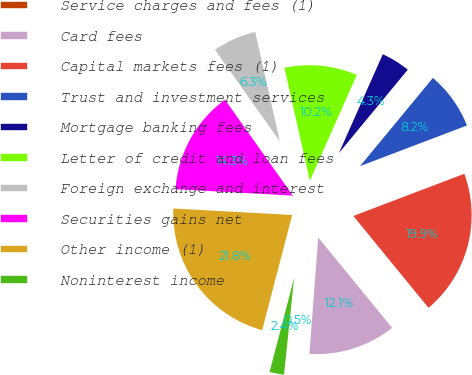Convert chart to OTSL. <chart><loc_0><loc_0><loc_500><loc_500><pie_chart><fcel>Service charges and fees (1)<fcel>Card fees<fcel>Capital markets fees (1)<fcel>Trust and investment services<fcel>Mortgage banking fees<fcel>Letter of credit and loan fees<fcel>Foreign exchange and interest<fcel>Securities gains net<fcel>Other income (1)<fcel>Noninterest income<nl><fcel>0.46%<fcel>12.11%<fcel>19.87%<fcel>8.23%<fcel>4.34%<fcel>10.17%<fcel>6.28%<fcel>14.33%<fcel>21.81%<fcel>2.4%<nl></chart> 